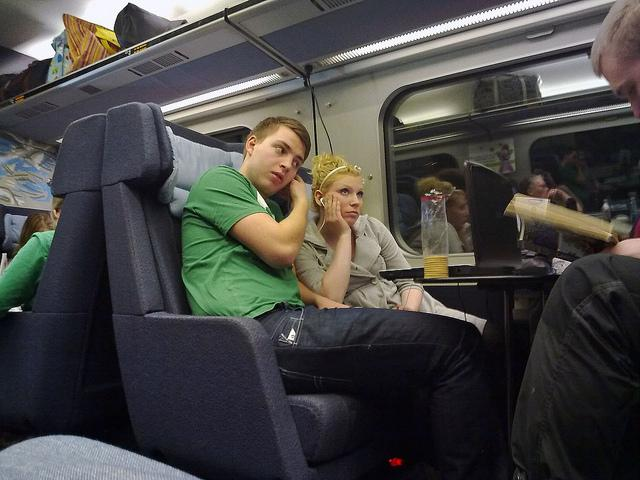What are the two young people doing with the headphones? Please explain your reasoning. listening. The people are watching something on the computer screen, most likely a movie, and are using the headphones to hear the dialogue. 